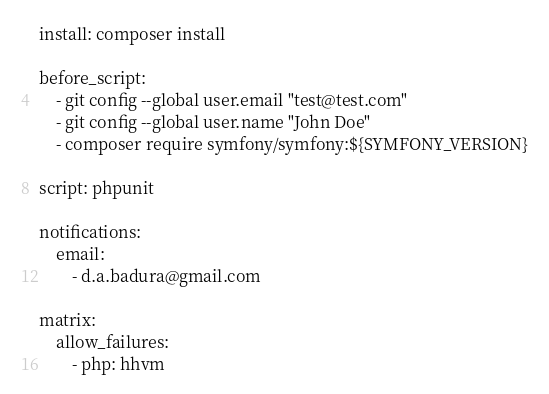Convert code to text. <code><loc_0><loc_0><loc_500><loc_500><_YAML_>
install: composer install

before_script:
    - git config --global user.email "test@test.com"
    - git config --global user.name "John Doe"
    - composer require symfony/symfony:${SYMFONY_VERSION}

script: phpunit

notifications:
    email:
        - d.a.badura@gmail.com

matrix:
    allow_failures:
        - php: hhvm
</code> 